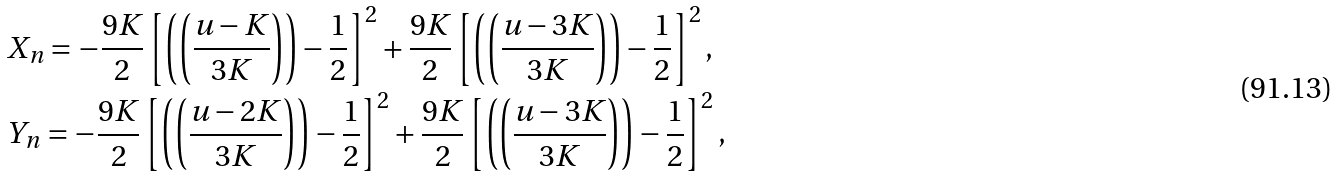<formula> <loc_0><loc_0><loc_500><loc_500>& X _ { n } = - \frac { 9 K } { 2 } \left [ \left ( \left ( \frac { u - K } { 3 K } \right ) \right ) - \frac { 1 } { 2 } \right ] ^ { 2 } + \frac { 9 K } { 2 } \left [ \left ( \left ( \frac { u - 3 K } { 3 K } \right ) \right ) - \frac { 1 } { 2 } \right ] ^ { 2 } , \\ & Y _ { n } = - \frac { 9 K } { 2 } \left [ \left ( \left ( \frac { u - 2 K } { 3 K } \right ) \right ) - \frac { 1 } { 2 } \right ] ^ { 2 } + \frac { 9 K } { 2 } \left [ \left ( \left ( \frac { u - 3 K } { 3 K } \right ) \right ) - \frac { 1 } { 2 } \right ] ^ { 2 } ,</formula> 